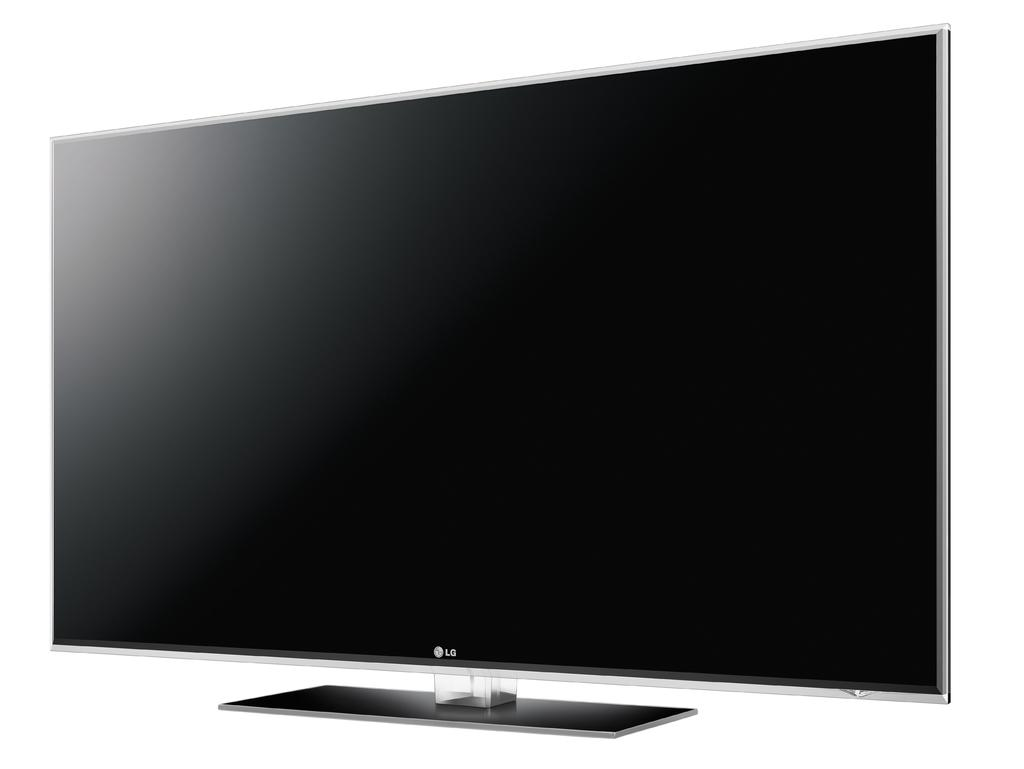<image>
Provide a brief description of the given image. A flat screen computer monitor with a blank screen. 